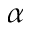Convert formula to latex. <formula><loc_0><loc_0><loc_500><loc_500>\alpha</formula> 